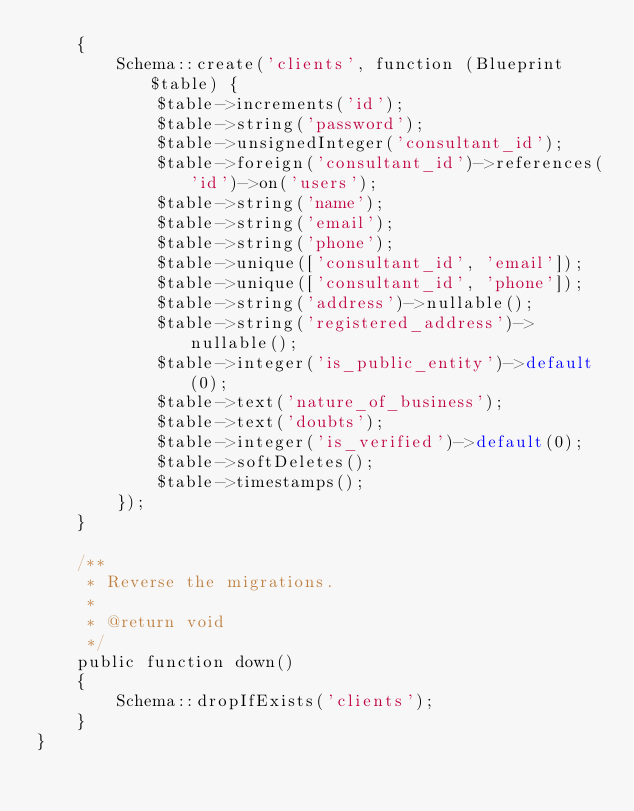<code> <loc_0><loc_0><loc_500><loc_500><_PHP_>    {
        Schema::create('clients', function (Blueprint $table) {
            $table->increments('id');
            $table->string('password');
            $table->unsignedInteger('consultant_id');
            $table->foreign('consultant_id')->references('id')->on('users');
            $table->string('name');
            $table->string('email');
            $table->string('phone');
            $table->unique(['consultant_id', 'email']);
            $table->unique(['consultant_id', 'phone']);
            $table->string('address')->nullable();
            $table->string('registered_address')->nullable();
            $table->integer('is_public_entity')->default(0);
            $table->text('nature_of_business');
            $table->text('doubts');
            $table->integer('is_verified')->default(0);
            $table->softDeletes();
            $table->timestamps();
        });
    }

    /**
     * Reverse the migrations.
     *
     * @return void
     */
    public function down()
    {
        Schema::dropIfExists('clients');
    }
}
</code> 